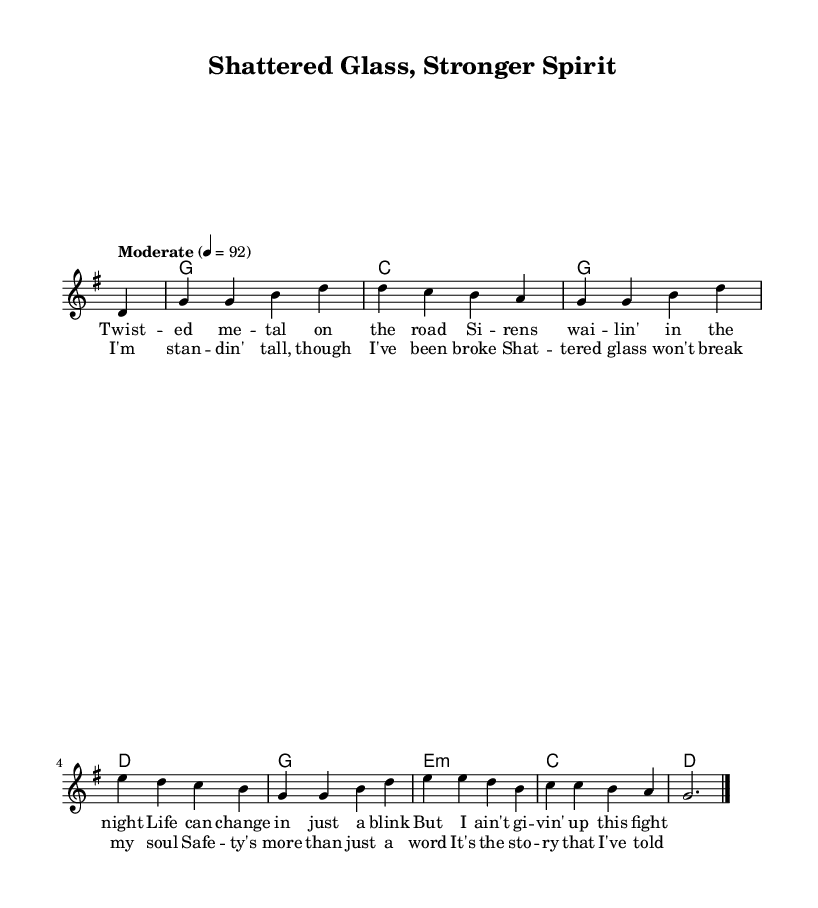What is the key signature of this music? The key signature is G major, which has one sharp (F#). You can find this information at the beginning of the score where it is indicated before the time signature.
Answer: G major What is the time signature of this music? The time signature is 4/4, shown in the beginning of the score. This indicates that there are four beats in each measure and the quarter note receives one beat.
Answer: 4/4 What is the tempo marking of this piece? The tempo marking indicates a moderate speed. In the score, it states "Moderate" with a BPM value of 92, meaning it is to be played at that speed.
Answer: 92 How many measures are there in the chorus? The chorus consists of four measures. By examining the lyric sections under the vocal line, we can count the number of measures that correspond to the lyrics provided.
Answer: Four Which chord is played on the first measure? The first measure contains a silence (notated with a partial rest). Checking the chord line in the harmonies section reveals that the first musical content starts on measure two.
Answer: Silence What theme is represented in the lyrics of this song? The lyrics convey a theme of resilience and strength despite adversity. The lines reflect the idea of not giving up, emphasizing personal strength after facing challenges.
Answer: Resilience What type of song is indicated by the subject matter and style? The song is a Country genre, evident through its lyrical content that focuses on personal struggle and emotional triumph, common themes in Country music.
Answer: Country 